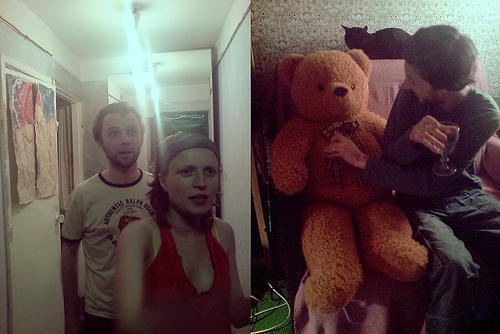How many teddy bears are in the image?
Give a very brief answer. 1. 